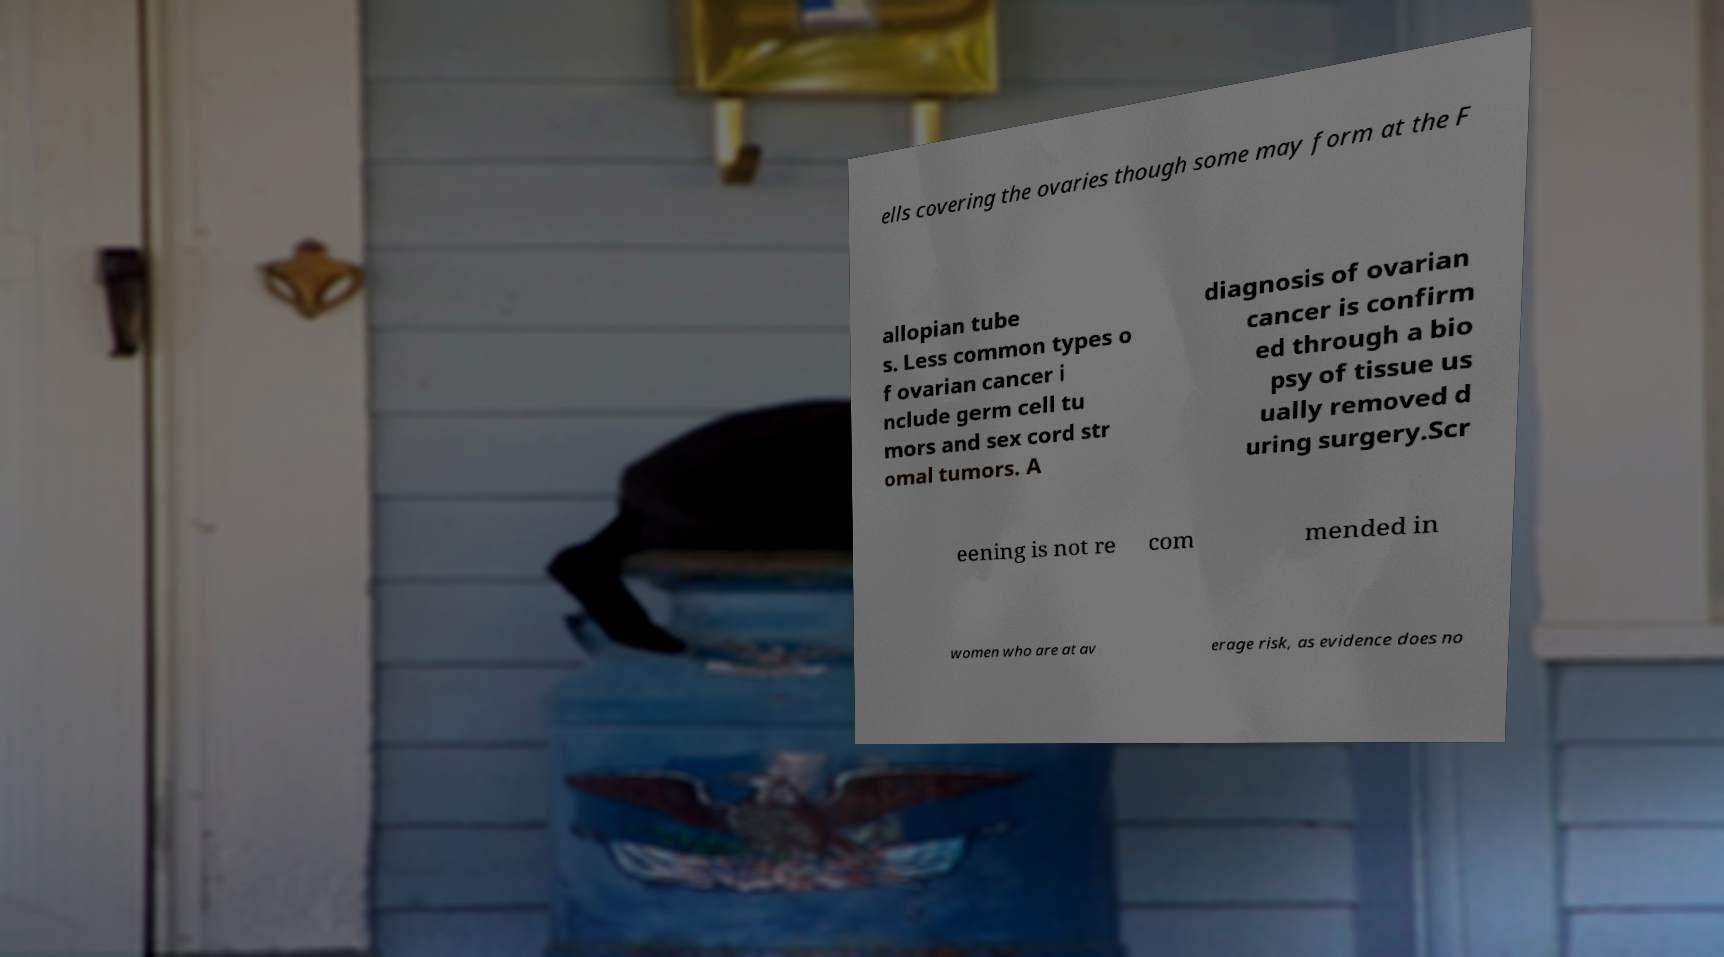Could you assist in decoding the text presented in this image and type it out clearly? ells covering the ovaries though some may form at the F allopian tube s. Less common types o f ovarian cancer i nclude germ cell tu mors and sex cord str omal tumors. A diagnosis of ovarian cancer is confirm ed through a bio psy of tissue us ually removed d uring surgery.Scr eening is not re com mended in women who are at av erage risk, as evidence does no 